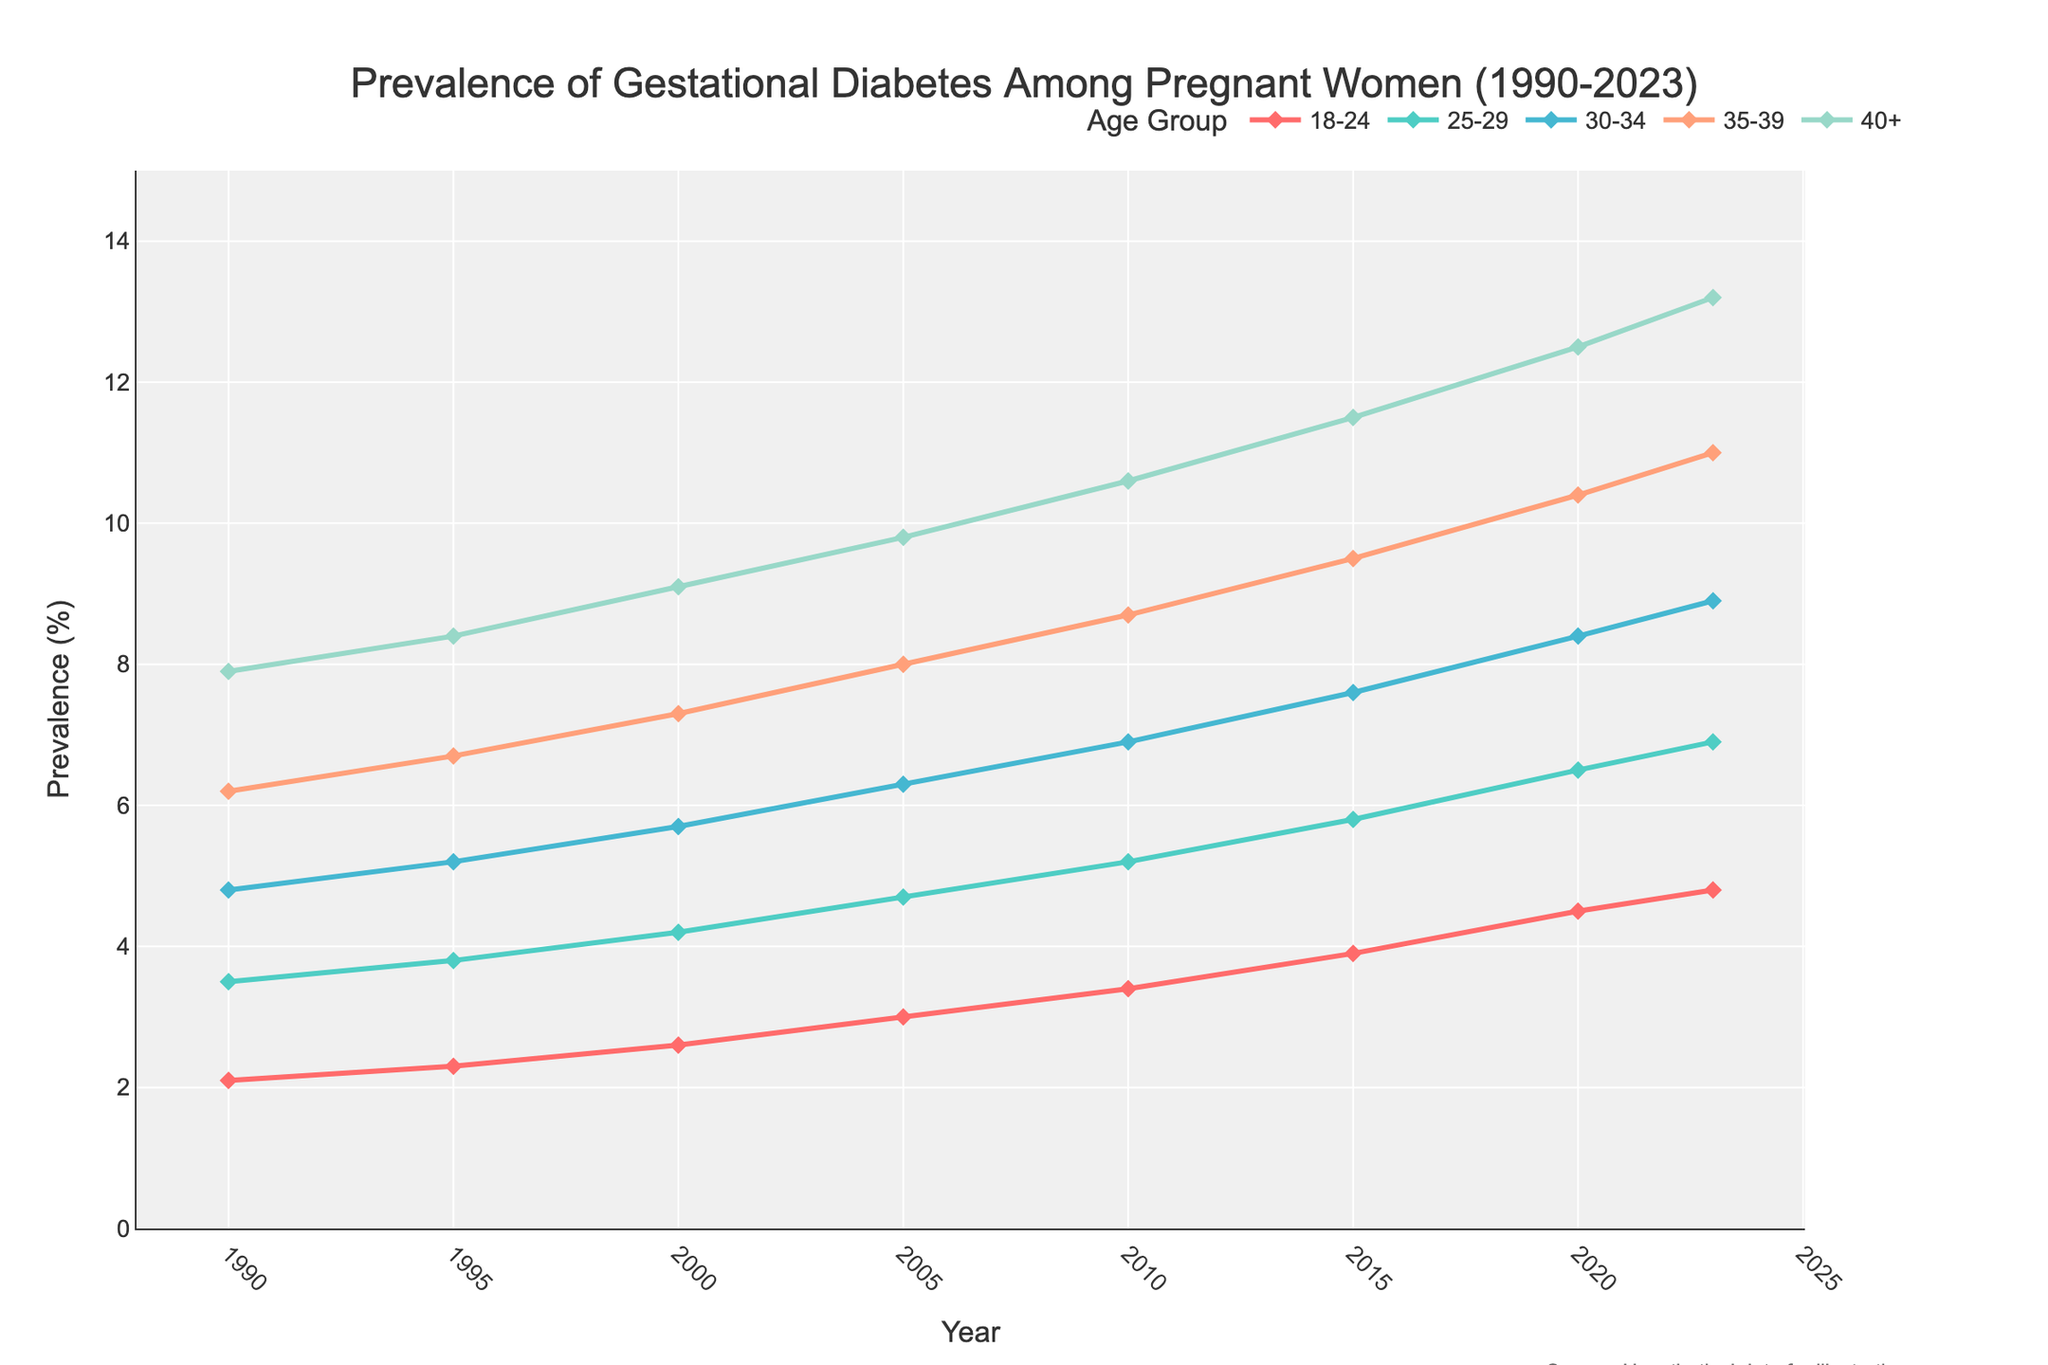What age group had the highest prevalence of gestational diabetes in 2023? To determine the age group with the highest prevalence in 2023, refer to the value at the far right of the line chart for each group. The age group '40+' has the highest prevalence.
Answer: 40+ Which year saw the prevalence of gestational diabetes for the 30-34 age group exceed 6%? Identify the year when the prevalence for the 30-34 age group first exceeds 6% by tracing the 30-34 line and finding the corresponding x-axis value. This happened in 2005.
Answer: 2005 What is the overall trend in the prevalence of gestational diabetes for all age groups from 1990 to 2023? Observe the direction and shape of each line for all age groups from 1990 to 2023. All lines show an upward trend, indicating increased prevalence over time.
Answer: Upward trend Which age group showed the largest increase in the prevalence of gestational diabetes from 1990 to 2023? Calculate the difference for each age group by subtracting the 1990 value from the 2023 value. The age group '40+' shows the largest increase (13.2 - 7.9 = 5.3).
Answer: 40+ By how much did the prevalence among women aged 18-24 increase from 1990 to 2023? Subtract the 1990 prevalence value for the 18-24 age group from the 2023 value: 4.8 - 2.1 = 2.7.
Answer: 2.7 In which year did the prevalence of gestational diabetes in the 25-29 age group reach 5%? Look for the year on the x-axis when the prevalence value for the 25-29 age group aligns with 5%. This occurred in 2010.
Answer: 2010 What was the prevalence of gestational diabetes for the 35-39 age group in 2015? Refer to the 2015 value on the line representing the 35-39 age group on the chart. The prevalence was 9.5%.
Answer: 9.5% Compare the prevalence of gestational diabetes between the youngest (18-24) and the oldest (40+) age groups in 2023. By how much is one higher than the other? Subtract the prevalence value for the 18-24 age group from that of the 40+ age group in 2023: 13.2 - 4.8 = 8.4.
Answer: 8.4 Which year showed the smallest difference between the 25-29 and 30-34 age groups? Calculate the absolute differences between the 25-29 and 30-34 prevalence values each year, then find the year with the smallest difference. In 1990, the difference was smallest (4.8 - 3.5 = 1.3).
Answer: 1990 How much higher was the prevalence of gestational diabetes for the 40+ age group compared to the 18-24 age group in 2020? Subtract the prevalence value for the 18-24 age group from that of the 40+ age group in 2020: 12.5 - 4.5 = 8.
Answer: 8 